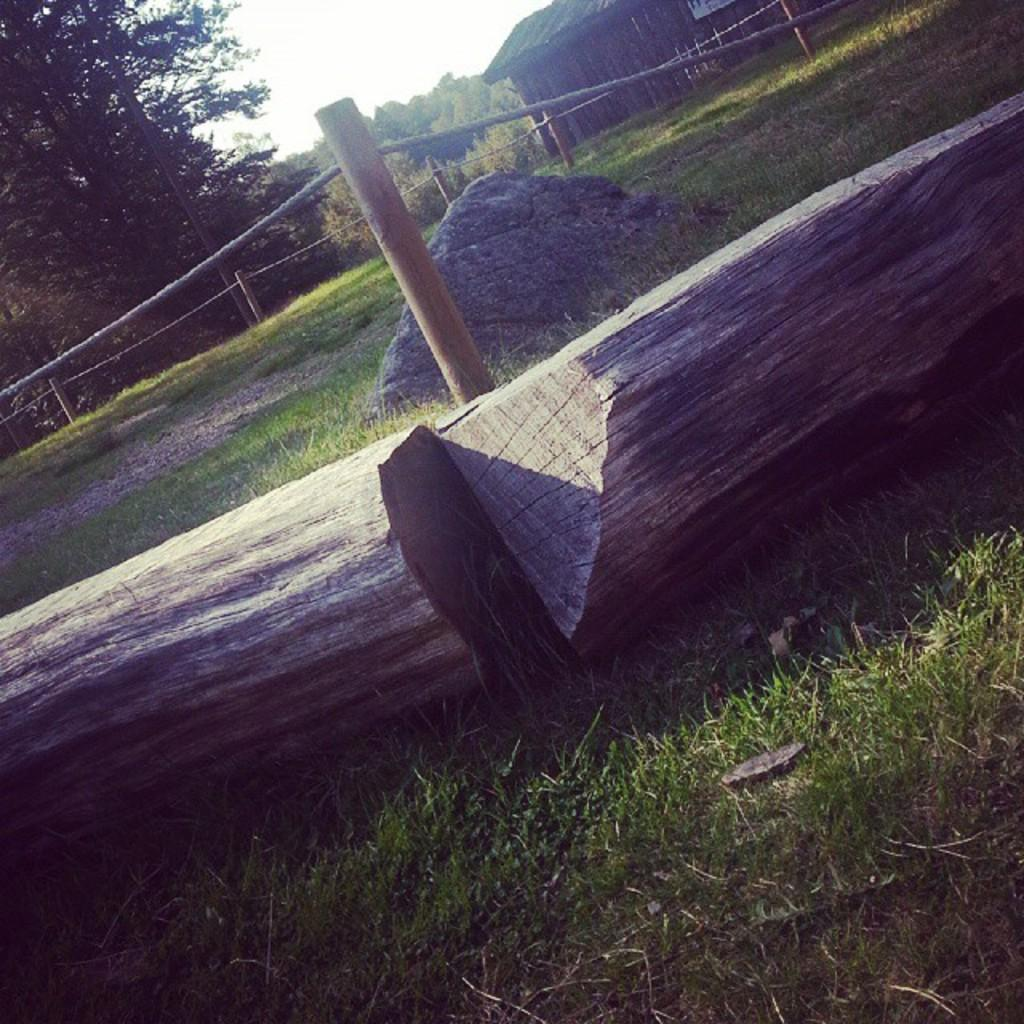What type of natural material can be seen in the image? There are wooden logs in the image. What man-made structure is present in the image? There is a fence in the image. What is another natural element visible in the image? There is a rock in the image. What type of vegetation can be seen in the image? There are trees and grass in the image. What type of building is present in the image? There is a house in the image. What is visible in the background of the image? The sky is visible in the background of the image. What type of linen is draped over the rock in the image? There is no linen present in the image; it only features wooden logs, a fence, a rock, trees, grass, a house, and the sky. Who is the crook mentioned in the image? There is no mention of a crook or any person in the image. 